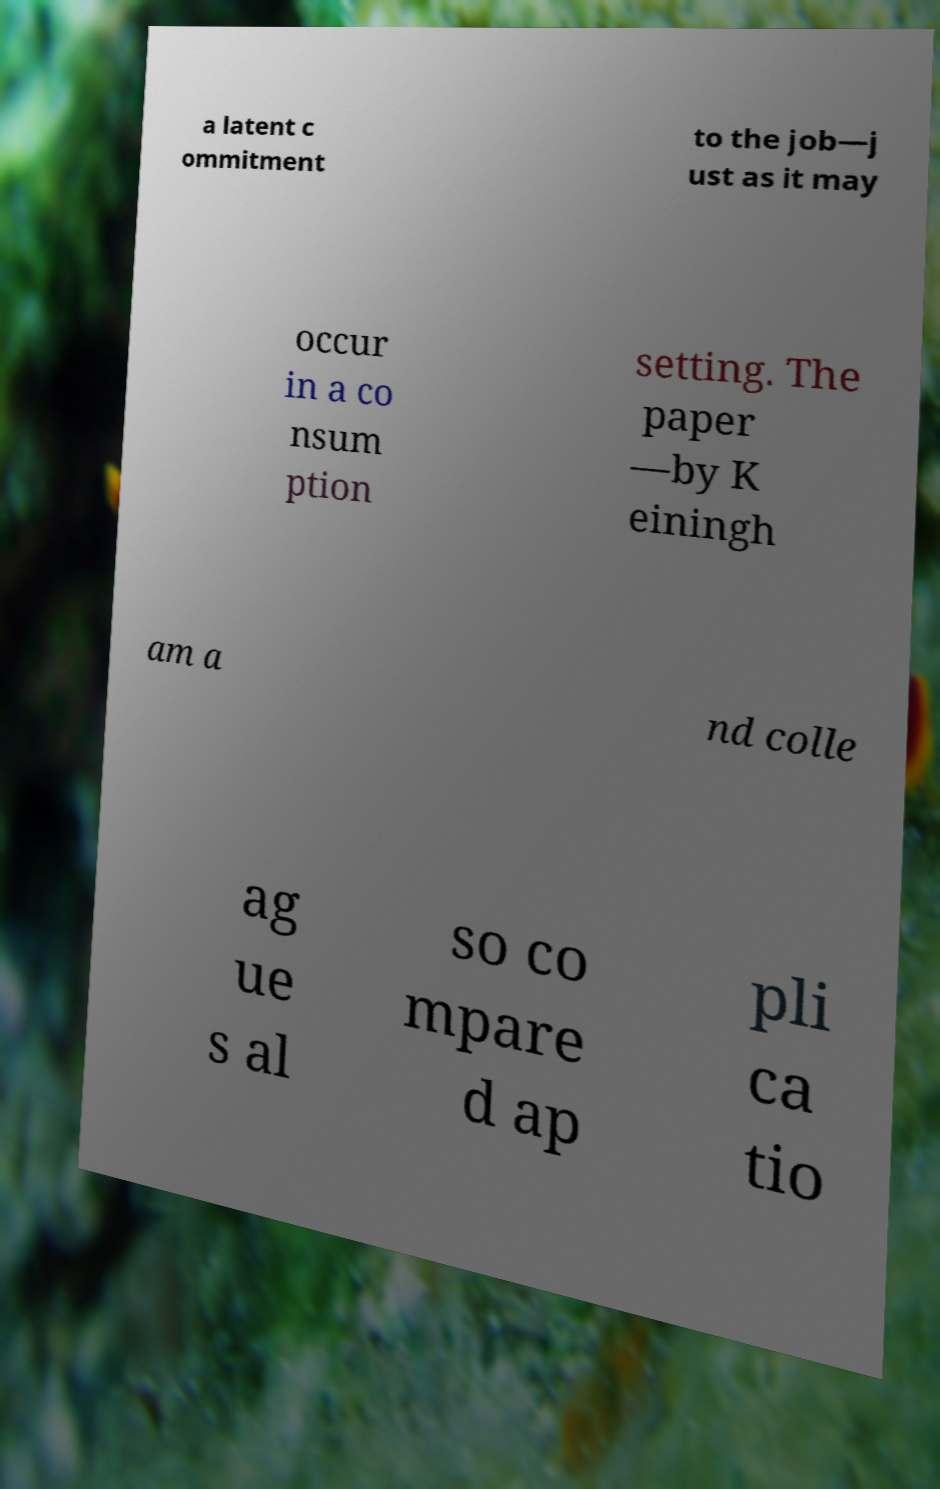Could you assist in decoding the text presented in this image and type it out clearly? a latent c ommitment to the job—j ust as it may occur in a co nsum ption setting. The paper —by K einingh am a nd colle ag ue s al so co mpare d ap pli ca tio 